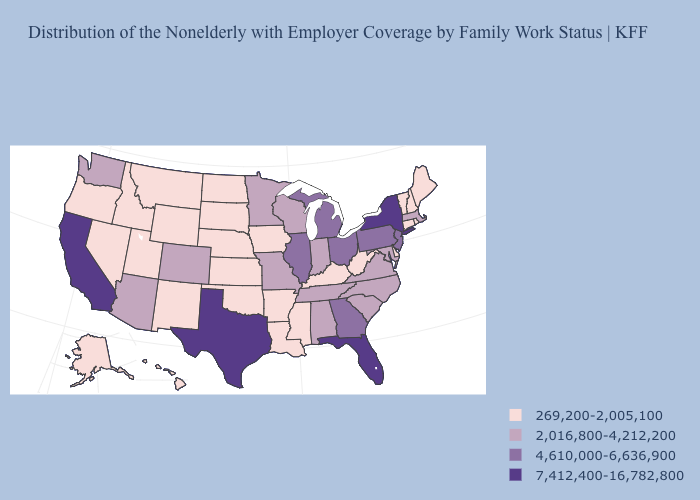Which states have the highest value in the USA?
Write a very short answer. California, Florida, New York, Texas. What is the value of Maine?
Answer briefly. 269,200-2,005,100. Name the states that have a value in the range 4,610,000-6,636,900?
Write a very short answer. Georgia, Illinois, Michigan, New Jersey, Ohio, Pennsylvania. What is the lowest value in states that border Delaware?
Write a very short answer. 2,016,800-4,212,200. Does Maryland have the lowest value in the South?
Be succinct. No. Which states have the lowest value in the West?
Be succinct. Alaska, Hawaii, Idaho, Montana, Nevada, New Mexico, Oregon, Utah, Wyoming. Which states hav the highest value in the MidWest?
Concise answer only. Illinois, Michigan, Ohio. Name the states that have a value in the range 7,412,400-16,782,800?
Answer briefly. California, Florida, New York, Texas. Does New York have the same value as Texas?
Quick response, please. Yes. Which states have the highest value in the USA?
Write a very short answer. California, Florida, New York, Texas. Does Alabama have the highest value in the USA?
Keep it brief. No. Does Kentucky have the highest value in the South?
Be succinct. No. What is the highest value in the USA?
Concise answer only. 7,412,400-16,782,800. What is the value of North Carolina?
Keep it brief. 2,016,800-4,212,200. Name the states that have a value in the range 4,610,000-6,636,900?
Concise answer only. Georgia, Illinois, Michigan, New Jersey, Ohio, Pennsylvania. 